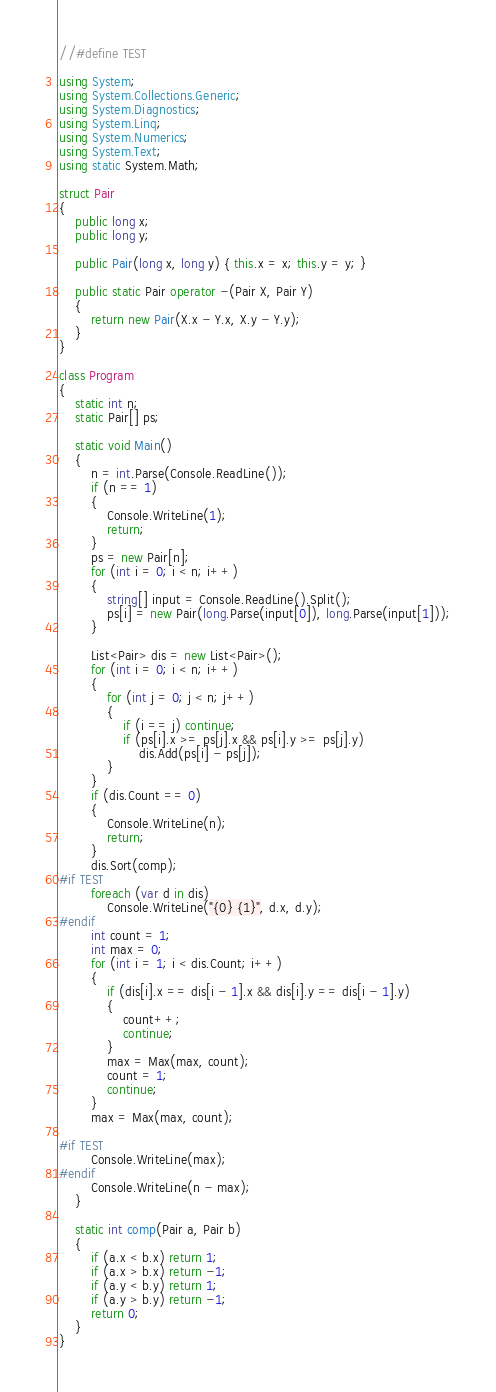<code> <loc_0><loc_0><loc_500><loc_500><_C#_>//#define TEST

using System;
using System.Collections.Generic;
using System.Diagnostics;
using System.Linq;
using System.Numerics;
using System.Text;
using static System.Math;

struct Pair
{
    public long x;
    public long y;

    public Pair(long x, long y) { this.x = x; this.y = y; }

    public static Pair operator -(Pair X, Pair Y)
    {
        return new Pair(X.x - Y.x, X.y - Y.y);
    }
}

class Program
{
    static int n;
    static Pair[] ps;

    static void Main()
    {
        n = int.Parse(Console.ReadLine());
        if (n == 1)
        {
            Console.WriteLine(1);
            return;
        }
        ps = new Pair[n];
        for (int i = 0; i < n; i++)
        {
            string[] input = Console.ReadLine().Split();
            ps[i] = new Pair(long.Parse(input[0]), long.Parse(input[1]));
        }

        List<Pair> dis = new List<Pair>();
        for (int i = 0; i < n; i++)
        {
            for (int j = 0; j < n; j++)
            {
                if (i == j) continue;
                if (ps[i].x >= ps[j].x && ps[i].y >= ps[j].y)
                    dis.Add(ps[i] - ps[j]);
            }
        }
        if (dis.Count == 0)
        {
            Console.WriteLine(n);
            return;
        }
        dis.Sort(comp);
#if TEST
        foreach (var d in dis)
            Console.WriteLine("{0} {1}", d.x, d.y);
#endif
        int count = 1;
        int max = 0;
        for (int i = 1; i < dis.Count; i++)
        {
            if (dis[i].x == dis[i - 1].x && dis[i].y == dis[i - 1].y)
            {
                count++;
                continue;
            }
            max = Max(max, count);
            count = 1;
            continue;
        }
        max = Max(max, count);

#if TEST
        Console.WriteLine(max);
#endif
        Console.WriteLine(n - max);
    }

    static int comp(Pair a, Pair b)
    {
        if (a.x < b.x) return 1;
        if (a.x > b.x) return -1;
        if (a.y < b.y) return 1;
        if (a.y > b.y) return -1;
        return 0;
    }
}
</code> 